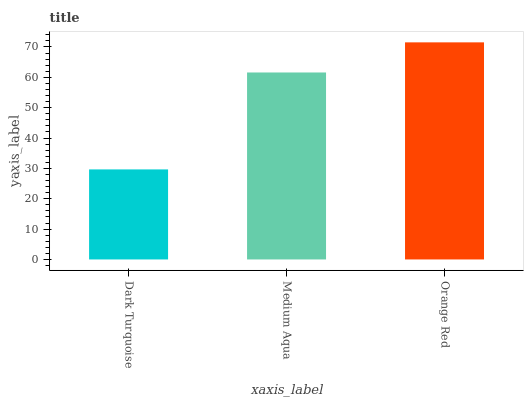Is Dark Turquoise the minimum?
Answer yes or no. Yes. Is Orange Red the maximum?
Answer yes or no. Yes. Is Medium Aqua the minimum?
Answer yes or no. No. Is Medium Aqua the maximum?
Answer yes or no. No. Is Medium Aqua greater than Dark Turquoise?
Answer yes or no. Yes. Is Dark Turquoise less than Medium Aqua?
Answer yes or no. Yes. Is Dark Turquoise greater than Medium Aqua?
Answer yes or no. No. Is Medium Aqua less than Dark Turquoise?
Answer yes or no. No. Is Medium Aqua the high median?
Answer yes or no. Yes. Is Medium Aqua the low median?
Answer yes or no. Yes. Is Orange Red the high median?
Answer yes or no. No. Is Dark Turquoise the low median?
Answer yes or no. No. 